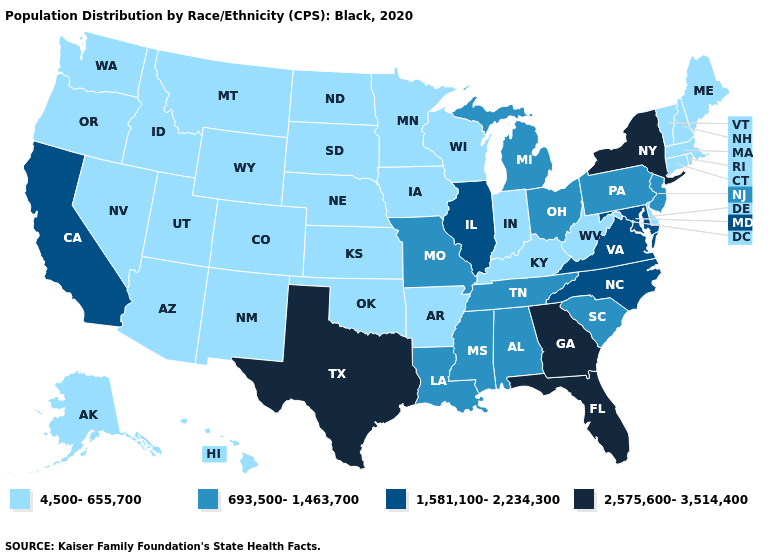Name the states that have a value in the range 4,500-655,700?
Answer briefly. Alaska, Arizona, Arkansas, Colorado, Connecticut, Delaware, Hawaii, Idaho, Indiana, Iowa, Kansas, Kentucky, Maine, Massachusetts, Minnesota, Montana, Nebraska, Nevada, New Hampshire, New Mexico, North Dakota, Oklahoma, Oregon, Rhode Island, South Dakota, Utah, Vermont, Washington, West Virginia, Wisconsin, Wyoming. Name the states that have a value in the range 4,500-655,700?
Keep it brief. Alaska, Arizona, Arkansas, Colorado, Connecticut, Delaware, Hawaii, Idaho, Indiana, Iowa, Kansas, Kentucky, Maine, Massachusetts, Minnesota, Montana, Nebraska, Nevada, New Hampshire, New Mexico, North Dakota, Oklahoma, Oregon, Rhode Island, South Dakota, Utah, Vermont, Washington, West Virginia, Wisconsin, Wyoming. Does Nevada have the highest value in the West?
Keep it brief. No. Name the states that have a value in the range 693,500-1,463,700?
Be succinct. Alabama, Louisiana, Michigan, Mississippi, Missouri, New Jersey, Ohio, Pennsylvania, South Carolina, Tennessee. Does New York have the highest value in the USA?
Concise answer only. Yes. What is the value of South Carolina?
Give a very brief answer. 693,500-1,463,700. What is the value of Alaska?
Quick response, please. 4,500-655,700. Does California have the lowest value in the West?
Short answer required. No. What is the highest value in the Northeast ?
Short answer required. 2,575,600-3,514,400. Which states hav the highest value in the MidWest?
Be succinct. Illinois. Name the states that have a value in the range 2,575,600-3,514,400?
Short answer required. Florida, Georgia, New York, Texas. Name the states that have a value in the range 2,575,600-3,514,400?
Answer briefly. Florida, Georgia, New York, Texas. What is the value of New York?
Keep it brief. 2,575,600-3,514,400. Among the states that border New York , which have the lowest value?
Answer briefly. Connecticut, Massachusetts, Vermont. Among the states that border Indiana , does Ohio have the lowest value?
Give a very brief answer. No. 